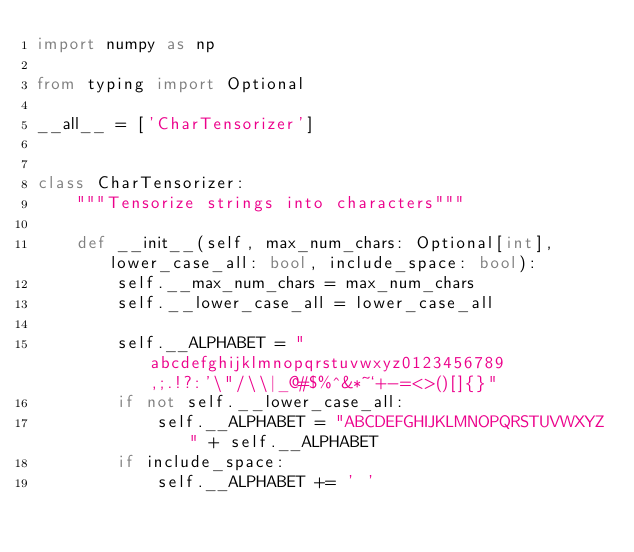Convert code to text. <code><loc_0><loc_0><loc_500><loc_500><_Python_>import numpy as np

from typing import Optional

__all__ = ['CharTensorizer']


class CharTensorizer:
    """Tensorize strings into characters"""

    def __init__(self, max_num_chars: Optional[int], lower_case_all: bool, include_space: bool):
        self.__max_num_chars = max_num_chars
        self.__lower_case_all = lower_case_all

        self.__ALPHABET = "abcdefghijklmnopqrstuvwxyz0123456789,;.!?:'\"/\\|_@#$%^&*~`+-=<>()[]{}"
        if not self.__lower_case_all:
            self.__ALPHABET = "ABCDEFGHIJKLMNOPQRSTUVWXYZ" + self.__ALPHABET
        if include_space:
            self.__ALPHABET += ' '
</code> 